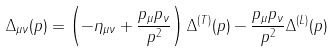<formula> <loc_0><loc_0><loc_500><loc_500>\Delta _ { \mu \nu } ( p ) = \left ( - \eta _ { \mu \nu } + \frac { p _ { \mu } p _ { \nu } } { p ^ { 2 } } \right ) \Delta ^ { ( T ) } ( p ) - \frac { p _ { \mu } p _ { \nu } } { p ^ { 2 } } \Delta ^ { ( L ) } ( p )</formula> 